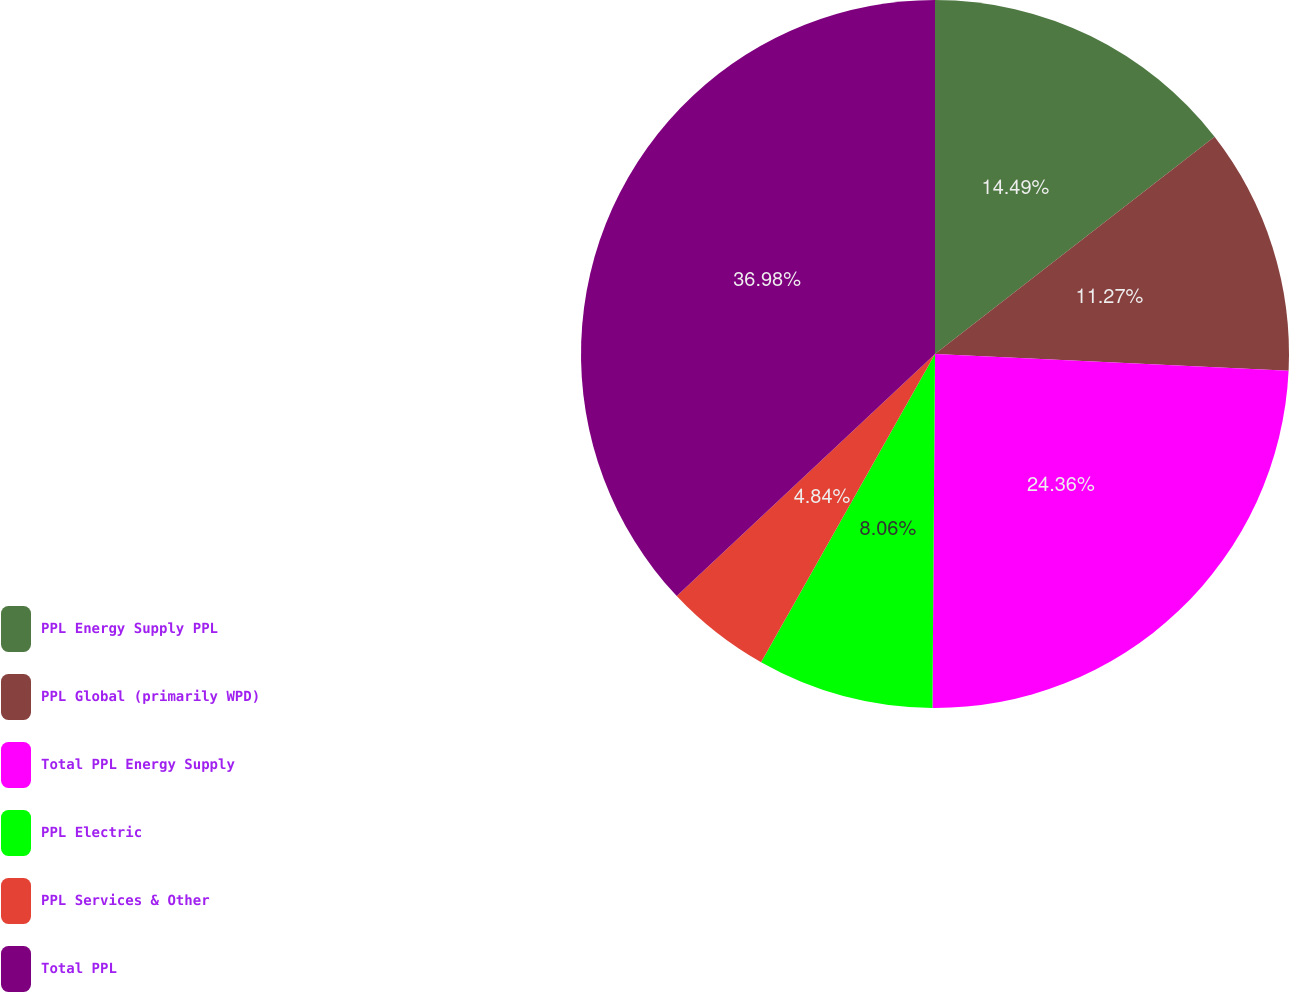Convert chart. <chart><loc_0><loc_0><loc_500><loc_500><pie_chart><fcel>PPL Energy Supply PPL<fcel>PPL Global (primarily WPD)<fcel>Total PPL Energy Supply<fcel>PPL Electric<fcel>PPL Services & Other<fcel>Total PPL<nl><fcel>14.49%<fcel>11.27%<fcel>24.36%<fcel>8.06%<fcel>4.84%<fcel>36.99%<nl></chart> 